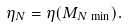Convert formula to latex. <formula><loc_0><loc_0><loc_500><loc_500>\eta _ { N } = \eta ( M _ { N \, \min } ) .</formula> 